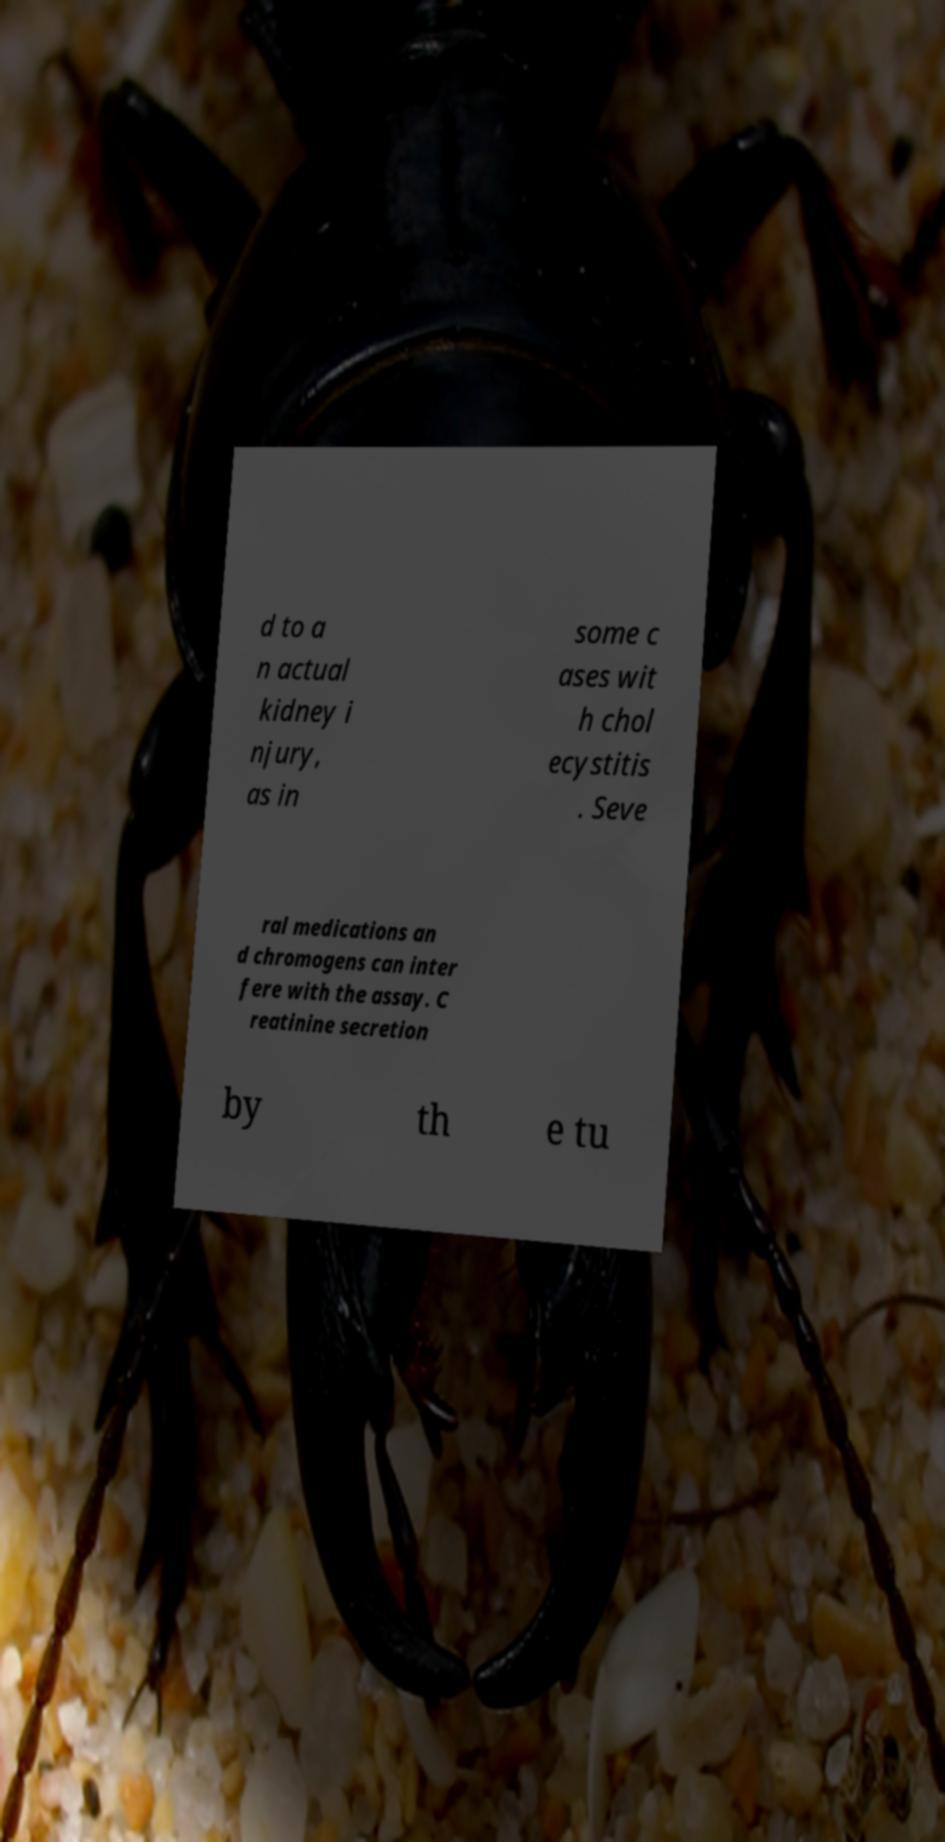Please identify and transcribe the text found in this image. d to a n actual kidney i njury, as in some c ases wit h chol ecystitis . Seve ral medications an d chromogens can inter fere with the assay. C reatinine secretion by th e tu 